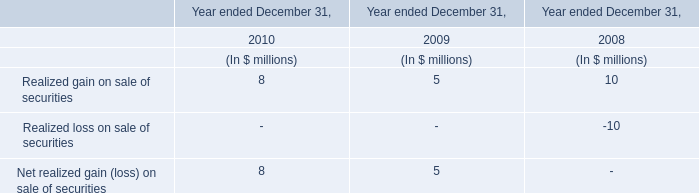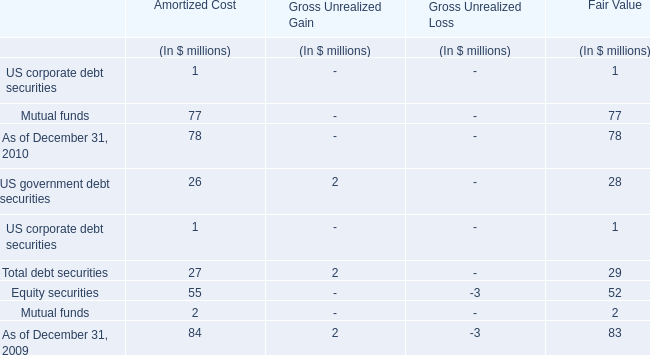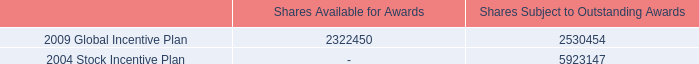What's the growth rate of Realized gain on sale of securities in 2010? 
Computations: ((8 - 5) / 8)
Answer: 0.375. 